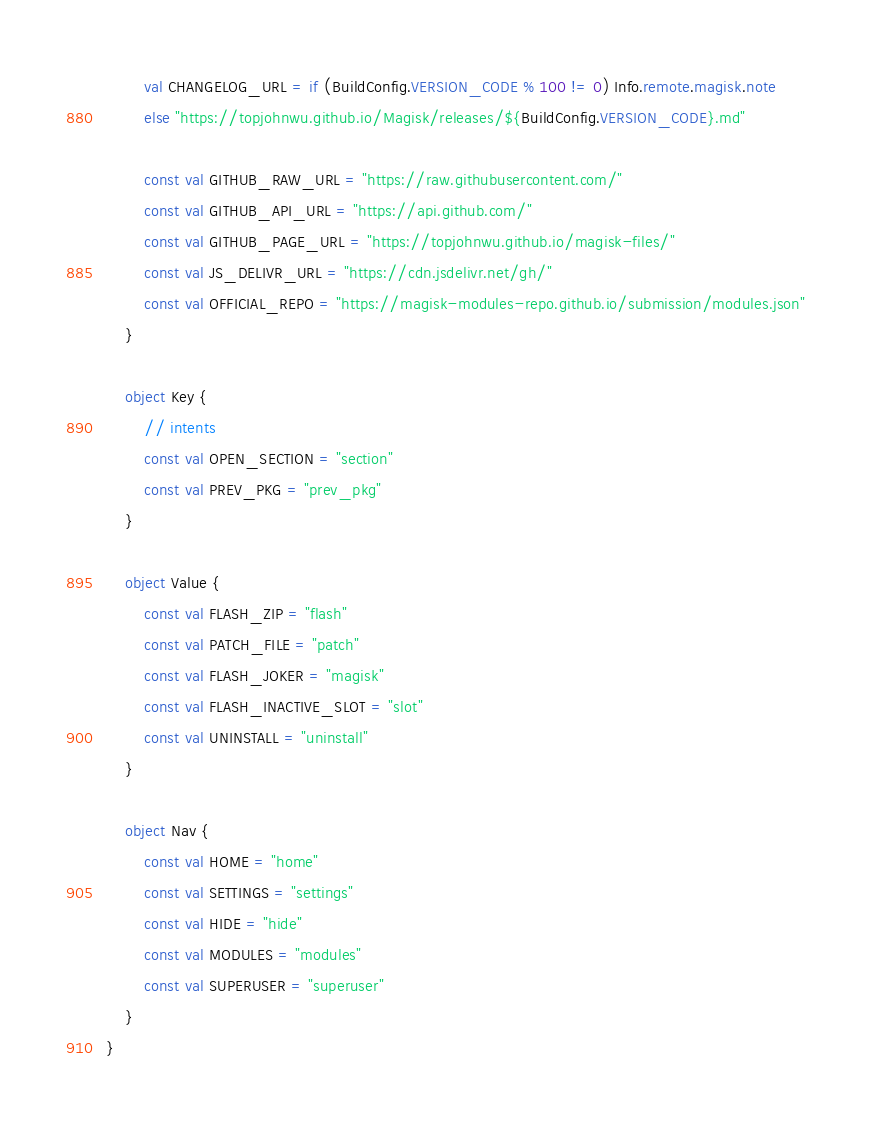<code> <loc_0><loc_0><loc_500><loc_500><_Kotlin_>        val CHANGELOG_URL = if (BuildConfig.VERSION_CODE % 100 != 0) Info.remote.magisk.note
        else "https://topjohnwu.github.io/Magisk/releases/${BuildConfig.VERSION_CODE}.md"

        const val GITHUB_RAW_URL = "https://raw.githubusercontent.com/"
        const val GITHUB_API_URL = "https://api.github.com/"
        const val GITHUB_PAGE_URL = "https://topjohnwu.github.io/magisk-files/"
        const val JS_DELIVR_URL = "https://cdn.jsdelivr.net/gh/"
        const val OFFICIAL_REPO = "https://magisk-modules-repo.github.io/submission/modules.json"
    }

    object Key {
        // intents
        const val OPEN_SECTION = "section"
        const val PREV_PKG = "prev_pkg"
    }

    object Value {
        const val FLASH_ZIP = "flash"
        const val PATCH_FILE = "patch"
        const val FLASH_JOKER = "magisk"
        const val FLASH_INACTIVE_SLOT = "slot"
        const val UNINSTALL = "uninstall"
    }

    object Nav {
        const val HOME = "home"
        const val SETTINGS = "settings"
        const val HIDE = "hide"
        const val MODULES = "modules"
        const val SUPERUSER = "superuser"
    }
}
</code> 